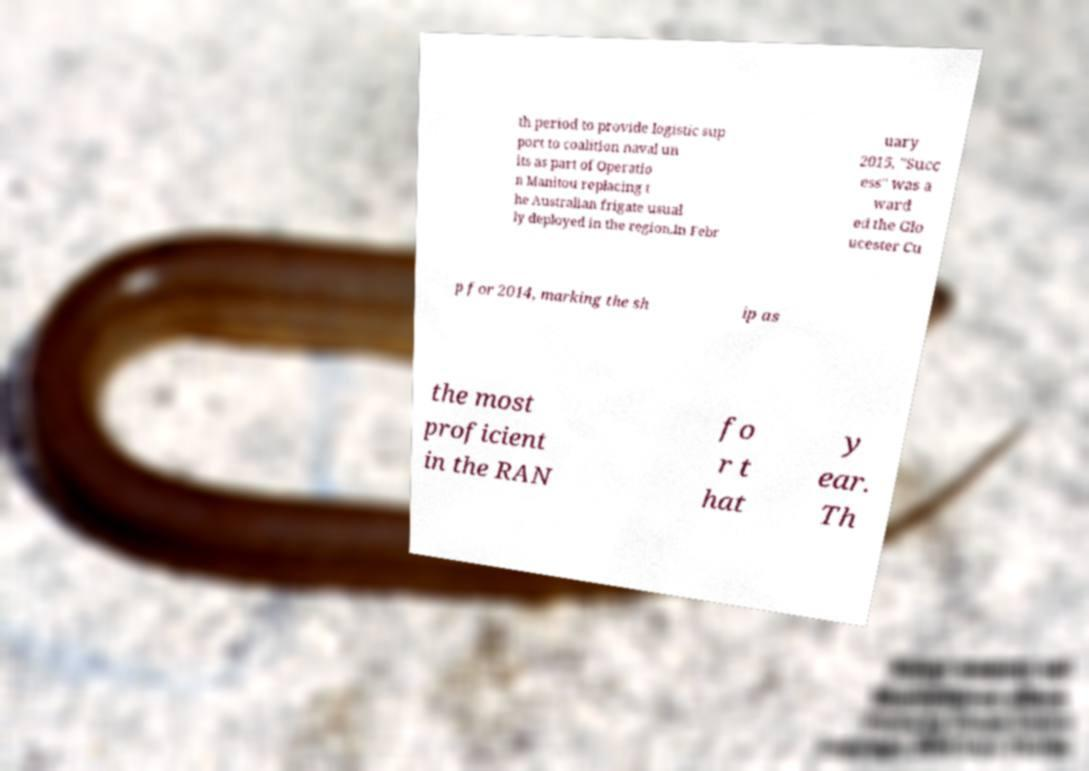For documentation purposes, I need the text within this image transcribed. Could you provide that? th period to provide logistic sup port to coalition naval un its as part of Operatio n Manitou replacing t he Australian frigate usual ly deployed in the region.In Febr uary 2015, "Succ ess" was a ward ed the Glo ucester Cu p for 2014, marking the sh ip as the most proficient in the RAN fo r t hat y ear. Th 